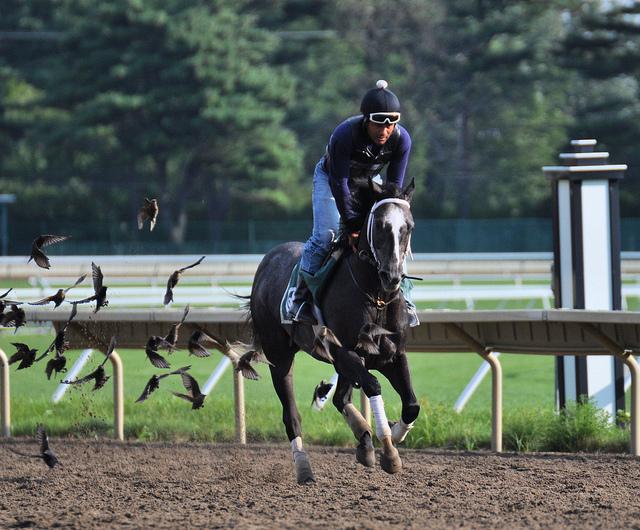Is the horse running?
Give a very brief answer. Yes. How many people are in the foto?
Be succinct. 1. How many birds are in the image?
Give a very brief answer. 15. Is the track muddy?
Write a very short answer. No. Is the horse completely clear of the obstacle?
Be succinct. Yes. Does the rider look happy?
Keep it brief. No. Is there grass in the image?
Short answer required. Yes. Is he riding near a lake?
Write a very short answer. No. Can you sit outdoors in this location?
Give a very brief answer. Yes. Is this horse running?
Quick response, please. Yes. What are the men standing on?
Write a very short answer. Horse. What color is the helmet?
Keep it brief. Black. How many horses are seen?
Write a very short answer. 1. Is the large animal well trained?
Quick response, please. Yes. Does the horse appeal healthy?
Quick response, please. Yes. 